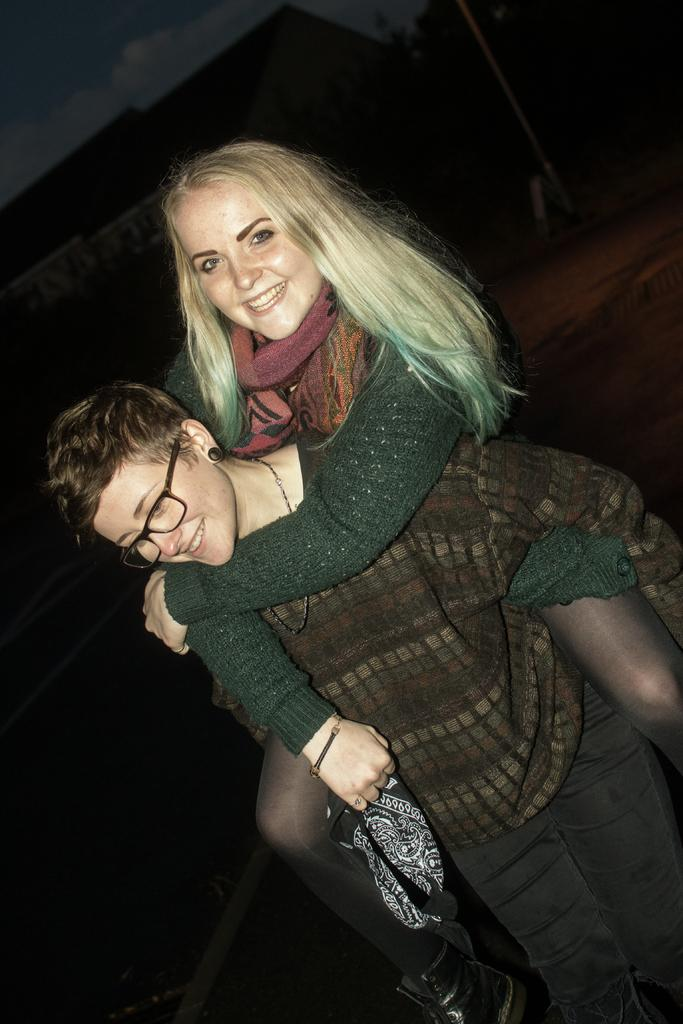How many people are in the image? There are two persons in the image. What are the expressions on their faces? Both persons are smiling. Can you describe the appearance of the person in the front? The person in the front is wearing spectacles. What is the color of the background in the image? The background of the image is dark. What can be seen at the top left of the image? The sky is visible at the left top of the image. What type of finger food is being consumed by the person in the image? There is no finger food present in the image. Is there a gun visible in the image? No, there is no gun present in the image. What type of milk is being served in the image? There is no milk present in the image. 